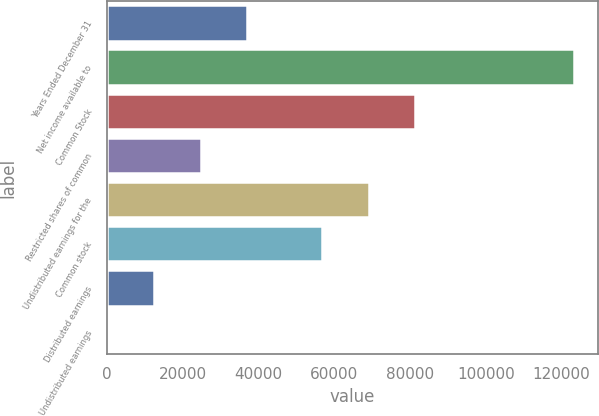<chart> <loc_0><loc_0><loc_500><loc_500><bar_chart><fcel>Years Ended December 31<fcel>Net income available to<fcel>Common Stock<fcel>Restricted shares of common<fcel>Undistributed earnings for the<fcel>Common stock<fcel>Distributed earnings<fcel>Undistributed earnings<nl><fcel>36999.2<fcel>123330<fcel>81328.9<fcel>24666.2<fcel>68996<fcel>56663<fcel>12333.2<fcel>0.26<nl></chart> 